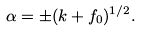Convert formula to latex. <formula><loc_0><loc_0><loc_500><loc_500>\alpha = \pm ( k + f _ { 0 } ) ^ { 1 / 2 } .</formula> 